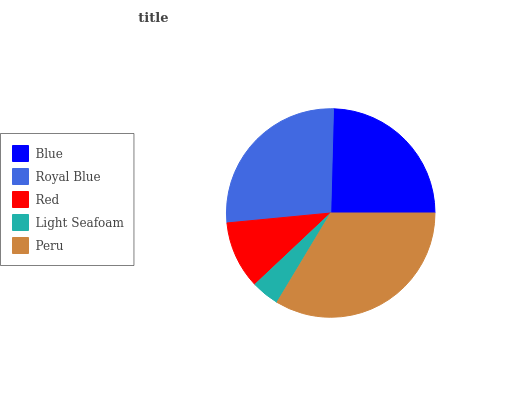Is Light Seafoam the minimum?
Answer yes or no. Yes. Is Peru the maximum?
Answer yes or no. Yes. Is Royal Blue the minimum?
Answer yes or no. No. Is Royal Blue the maximum?
Answer yes or no. No. Is Royal Blue greater than Blue?
Answer yes or no. Yes. Is Blue less than Royal Blue?
Answer yes or no. Yes. Is Blue greater than Royal Blue?
Answer yes or no. No. Is Royal Blue less than Blue?
Answer yes or no. No. Is Blue the high median?
Answer yes or no. Yes. Is Blue the low median?
Answer yes or no. Yes. Is Light Seafoam the high median?
Answer yes or no. No. Is Royal Blue the low median?
Answer yes or no. No. 